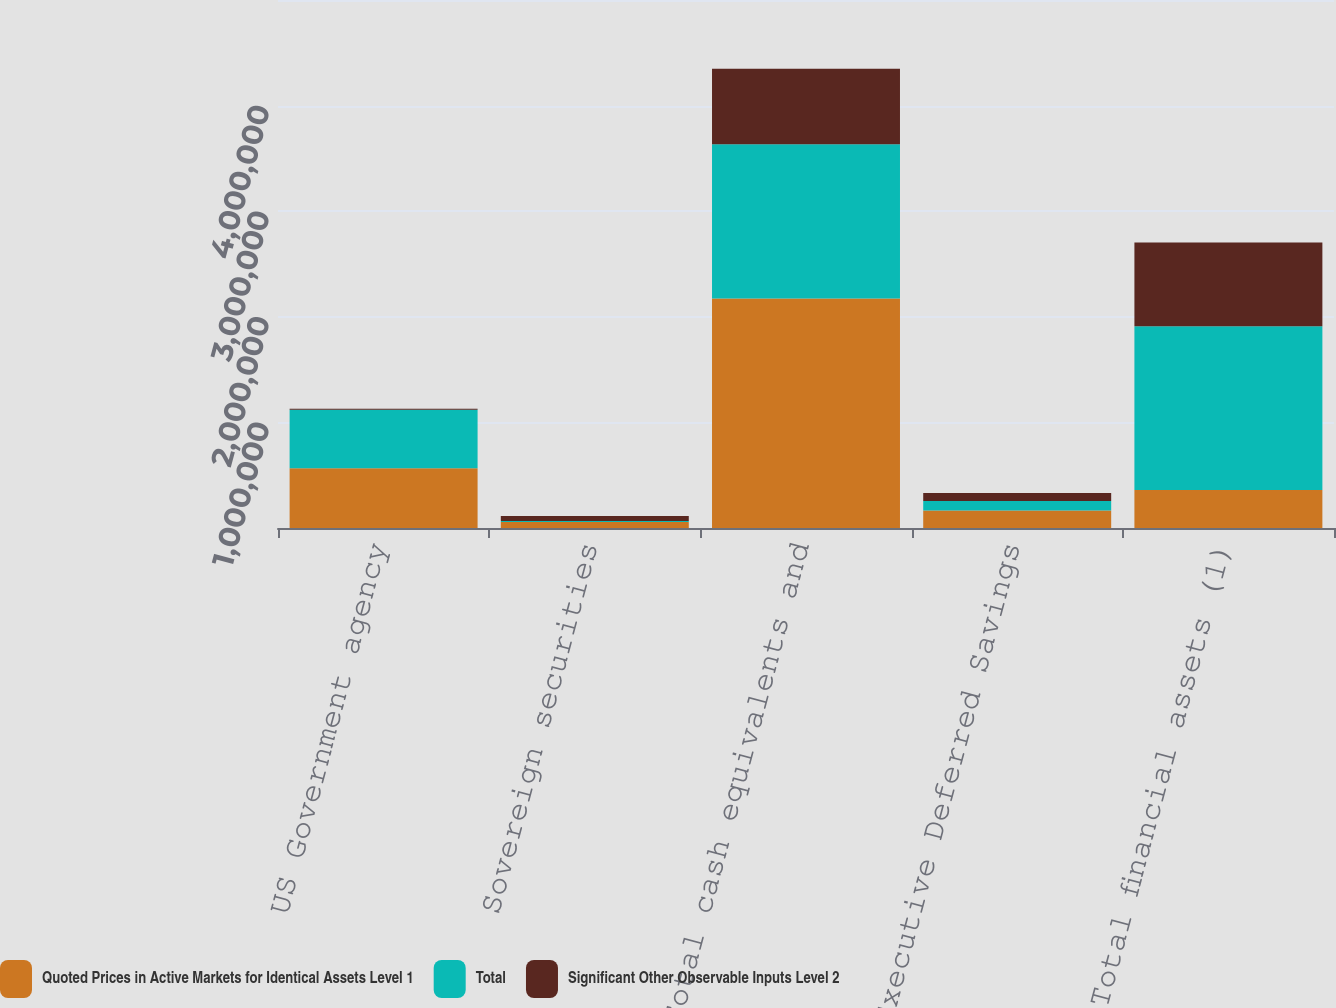Convert chart. <chart><loc_0><loc_0><loc_500><loc_500><stacked_bar_chart><ecel><fcel>US Government agency<fcel>Sovereign securities<fcel>Total cash equivalents and<fcel>Executive Deferred Savings<fcel>Total financial assets (1)<nl><fcel>Quoted Prices in Active Markets for Identical Assets Level 1<fcel>564768<fcel>57093<fcel>2.17408e+06<fcel>165655<fcel>360837<nl><fcel>Total<fcel>556019<fcel>8976<fcel>1.45944e+06<fcel>91203<fcel>1.55064e+06<nl><fcel>Significant Other Observable Inputs Level 2<fcel>8749<fcel>48117<fcel>714643<fcel>74452<fcel>792159<nl></chart> 